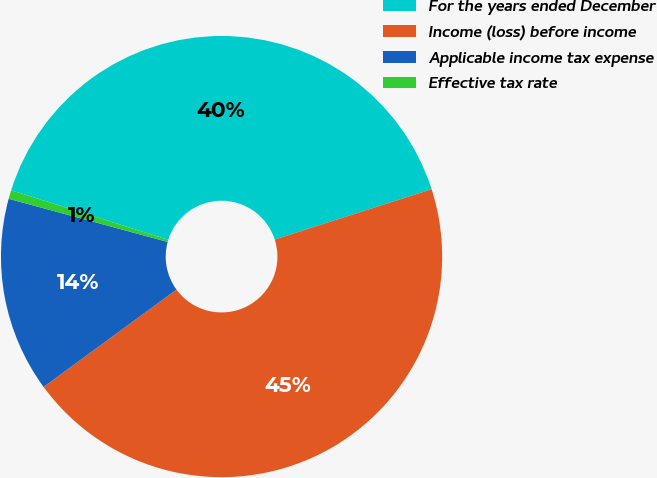Convert chart to OTSL. <chart><loc_0><loc_0><loc_500><loc_500><pie_chart><fcel>For the years ended December<fcel>Income (loss) before income<fcel>Applicable income tax expense<fcel>Effective tax rate<nl><fcel>40.2%<fcel>44.88%<fcel>14.28%<fcel>0.64%<nl></chart> 